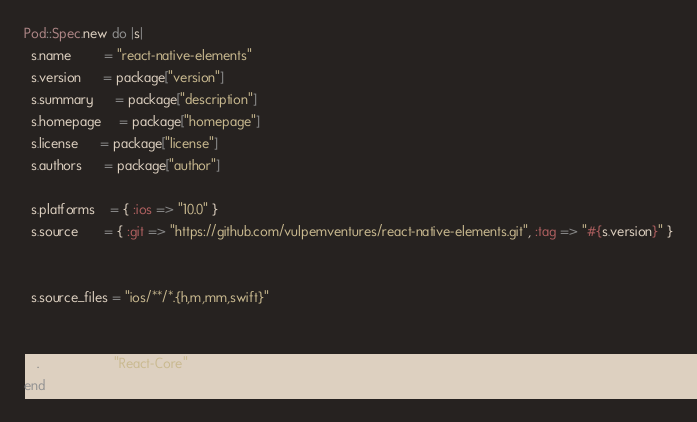<code> <loc_0><loc_0><loc_500><loc_500><_Ruby_>Pod::Spec.new do |s|
  s.name         = "react-native-elements"
  s.version      = package["version"]
  s.summary      = package["description"]
  s.homepage     = package["homepage"]
  s.license      = package["license"]
  s.authors      = package["author"]

  s.platforms    = { :ios => "10.0" }
  s.source       = { :git => "https://github.com/vulpemventures/react-native-elements.git", :tag => "#{s.version}" }

  
  s.source_files = "ios/**/*.{h,m,mm,swift}"
  

  s.dependency "React-Core"
end
</code> 